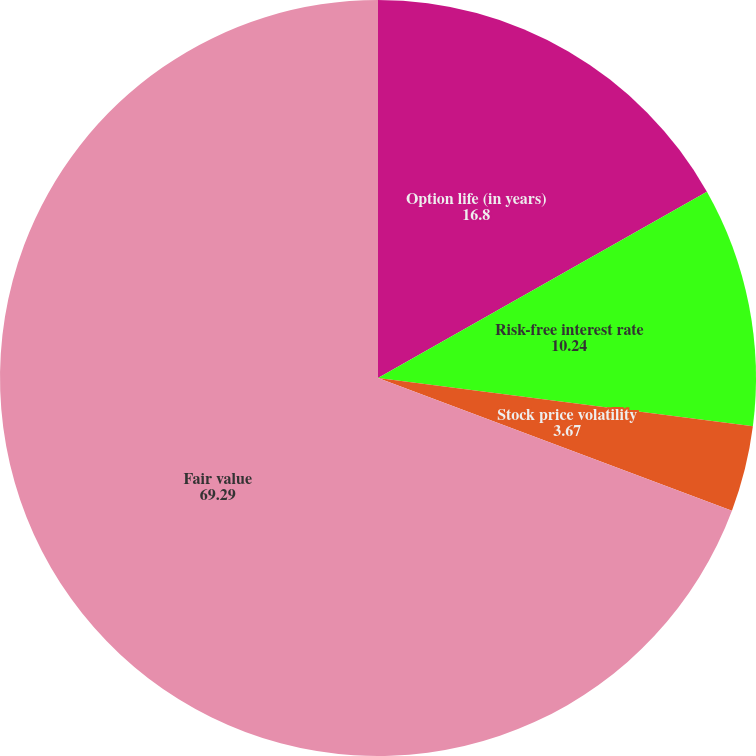<chart> <loc_0><loc_0><loc_500><loc_500><pie_chart><fcel>Option life (in years)<fcel>Risk-free interest rate<fcel>Stock price volatility<fcel>Fair value<nl><fcel>16.8%<fcel>10.24%<fcel>3.67%<fcel>69.29%<nl></chart> 